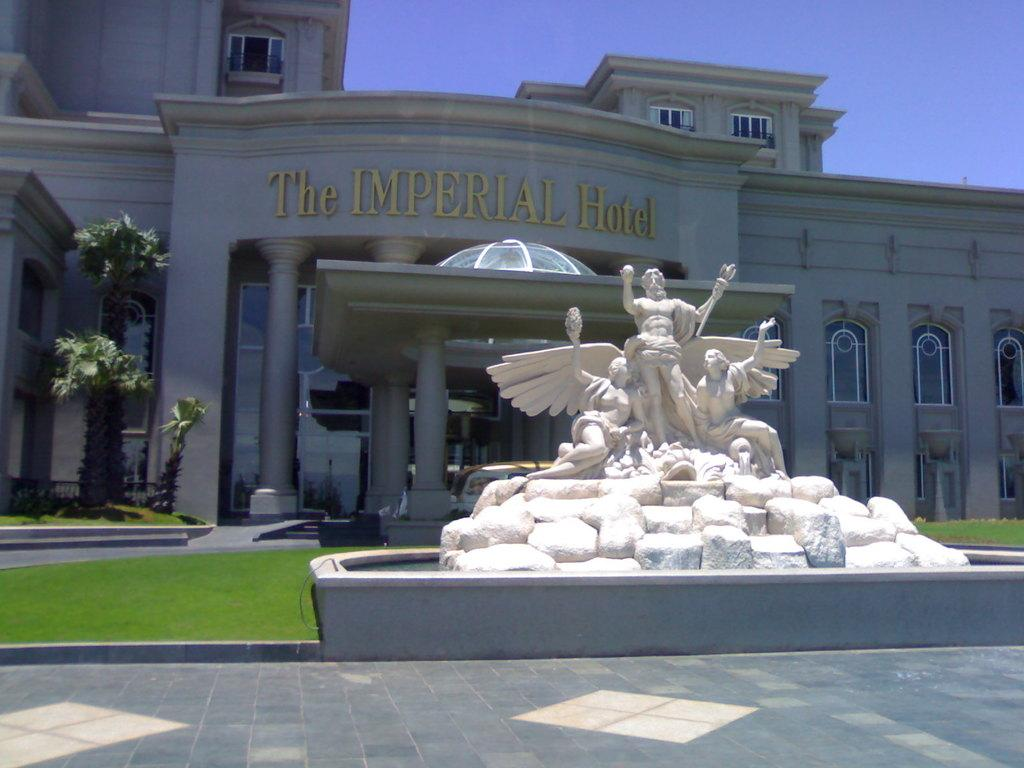What type: What type of structure is visible in the image? There is a building in the image. What features can be observed on the building? The building has windows and pillars. What natural elements are present in the image? There are trees and grass in the image. What man-made object can be seen in the image? There is a vehicle in the image. What artistic elements are present in the image? There are statues in the image. What other objects can be seen in the image? There are other objects in the image. What text can be read in the image? There is text on a wall in the image. What part of the natural environment is visible in the image? The sky is visible in the image. What type of crime is being committed in the image? There is no indication of any crime being committed in the image. What type of machine is being used to create the text on the wall? There is no machine visible in the image, and the text on the wall appears to be painted or printed. 